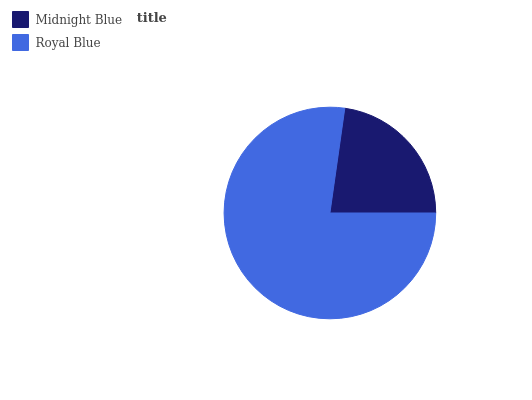Is Midnight Blue the minimum?
Answer yes or no. Yes. Is Royal Blue the maximum?
Answer yes or no. Yes. Is Royal Blue the minimum?
Answer yes or no. No. Is Royal Blue greater than Midnight Blue?
Answer yes or no. Yes. Is Midnight Blue less than Royal Blue?
Answer yes or no. Yes. Is Midnight Blue greater than Royal Blue?
Answer yes or no. No. Is Royal Blue less than Midnight Blue?
Answer yes or no. No. Is Royal Blue the high median?
Answer yes or no. Yes. Is Midnight Blue the low median?
Answer yes or no. Yes. Is Midnight Blue the high median?
Answer yes or no. No. Is Royal Blue the low median?
Answer yes or no. No. 